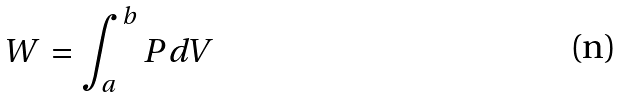<formula> <loc_0><loc_0><loc_500><loc_500>W = \int _ { a } ^ { b } P d V</formula> 